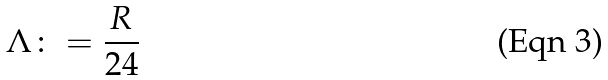<formula> <loc_0><loc_0><loc_500><loc_500>\Lambda \colon = \frac { R } { 2 4 }</formula> 